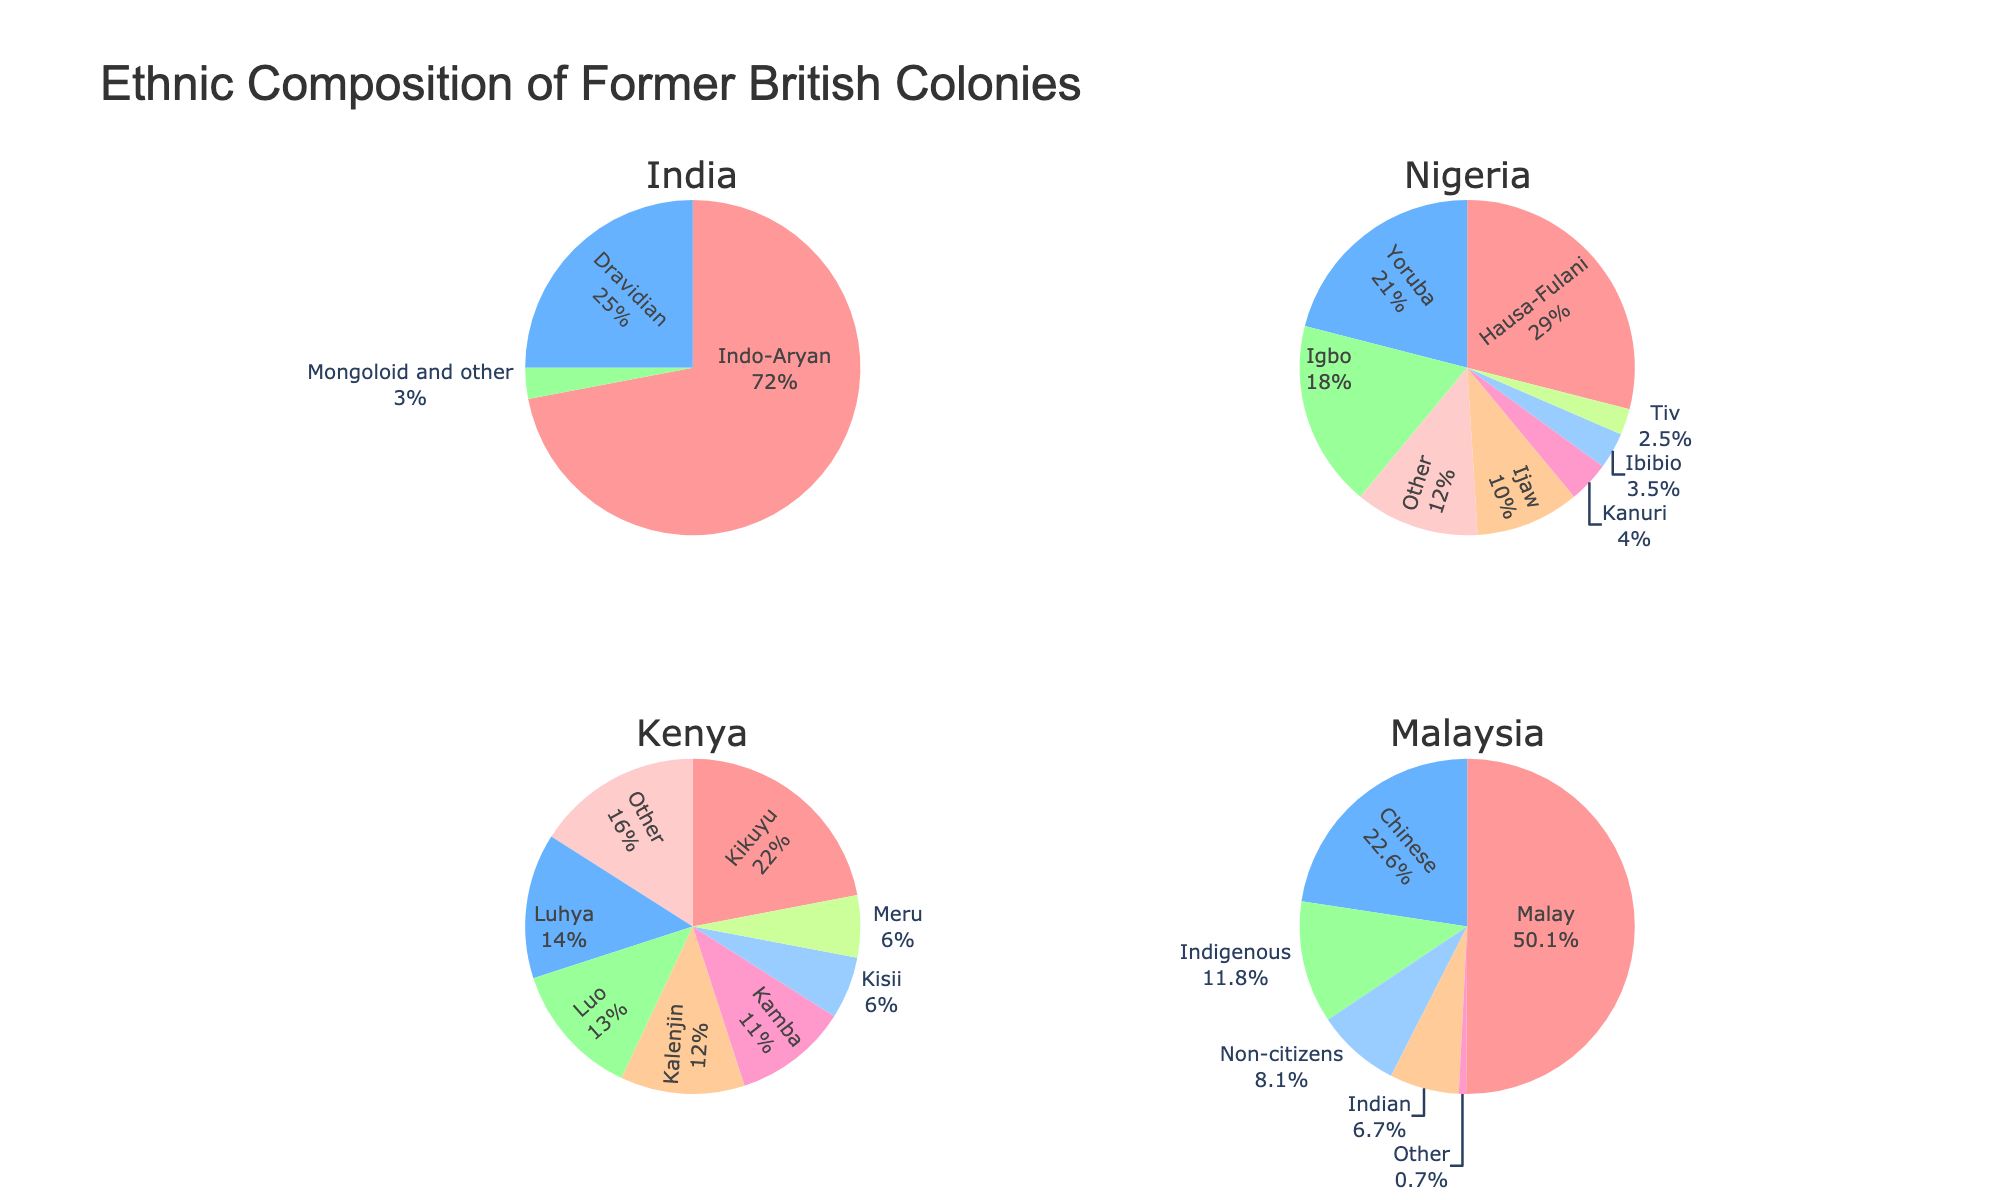What's the combined percentage of Hausa-Fulani, Yoruba, and Igbo in Nigeria? To find the combined percentage, add the percentages of Hausa-Fulani (29), Yoruba (21), and Igbo (18). Thus, 29 + 21 + 18 = 68%.
Answer: 68% Which country has the highest percentage of a single ethnic group, and which group is it? In India, the Indo-Aryan group has the highest percentage at 72%. No other ethnic group in any country surpasses this percentage.
Answer: India, Indo-Aryan In Malaysia, are there more people of Chinese ethnicity or Indian ethnicity based on percentage? The pie chart shows the Chinese ethnicity at 22.6% and Indian ethnicity at 6.7%. Therefore, there are more people of Chinese ethnicity.
Answer: Chinese What is the difference in the percentage of Kikuyu and Luhya in Kenya? Kikuyu is at 22% and Luhya at 14%. The difference is 22 - 14 = 8%.
Answer: 8% Among the listed ethnicities in the pie chart, which two groups have the closest percentages in Nigeria? Ijaw and Kanuri have percentages of 10% and 4%, respectively, but Ibibio and Tiv have closer percentages of 3.5% and 2.5%, with a difference of only 1%.
Answer: Ibibio and Tiv What is the percentage range of the ethnicities in Kenya? The highest percentage ethnicity in Kenya is Kikuyu at 22%, and the lowest among the major groups is Meru at 6%, giving a range of 22 - 6 = 16%.
Answer: 16% If you combine the "Other" categories from the three countries, what is their total percentage? India's "Other" is included in Mongoloid and other (3%), Nigeria's "Other" is 12%, and Kenya's "Other" is 16%. Adding these gives 3 + 12 + 16 = 31%.
Answer: 31% Out of the ethnic groups listed in India and Kenya, which group has the lowest percentage, and what is that percentage? Among the groups, Mongoloid and other in India have the lowest percentage of 3%.
Answer: Mongoloid and other, 3% In Malaysia, what percentage do the non-citizens represent and how does it compare to the percentage of the Indian ethnicity? Non-citizens in Malaysia represent 8.1% while the Indian ethnicity stands at 6.7%. Therefore, non-citizens have a higher percentage by 8.1 - 6.7 = 1.4%.
Answer: 1.4% How do the percentages of the Kalenjin and Kamba in Kenya compare visually in terms of the pie chart segments? The pie chart shows Kalenjin at 12% and Kamba at 11%. Visually, the Kalenjin segment is slightly larger than the Kamba segment given their 1% difference.
Answer: Kalenjin segment is larger 